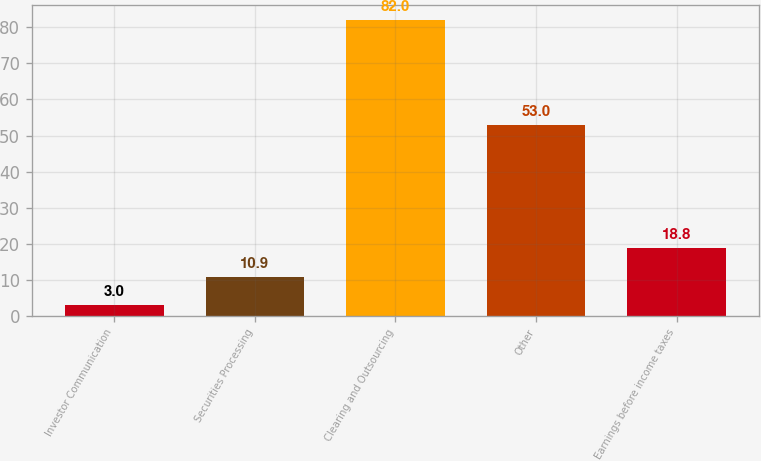Convert chart to OTSL. <chart><loc_0><loc_0><loc_500><loc_500><bar_chart><fcel>Investor Communication<fcel>Securities Processing<fcel>Clearing and Outsourcing<fcel>Other<fcel>Earnings before income taxes<nl><fcel>3<fcel>10.9<fcel>82<fcel>53<fcel>18.8<nl></chart> 